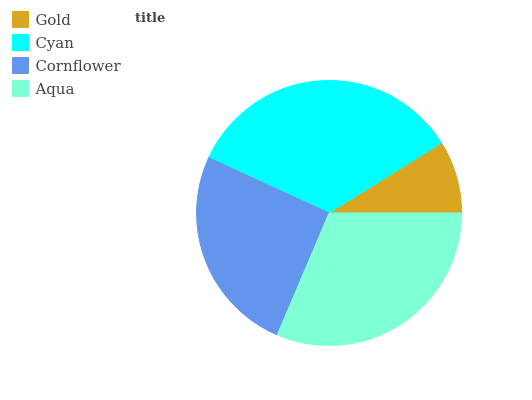Is Gold the minimum?
Answer yes or no. Yes. Is Cyan the maximum?
Answer yes or no. Yes. Is Cornflower the minimum?
Answer yes or no. No. Is Cornflower the maximum?
Answer yes or no. No. Is Cyan greater than Cornflower?
Answer yes or no. Yes. Is Cornflower less than Cyan?
Answer yes or no. Yes. Is Cornflower greater than Cyan?
Answer yes or no. No. Is Cyan less than Cornflower?
Answer yes or no. No. Is Aqua the high median?
Answer yes or no. Yes. Is Cornflower the low median?
Answer yes or no. Yes. Is Gold the high median?
Answer yes or no. No. Is Gold the low median?
Answer yes or no. No. 